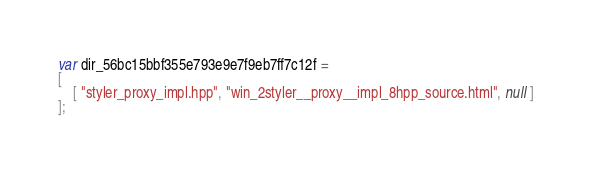<code> <loc_0><loc_0><loc_500><loc_500><_JavaScript_>var dir_56bc15bbf355e793e9e7f9eb7ff7c12f =
[
    [ "styler_proxy_impl.hpp", "win_2styler__proxy__impl_8hpp_source.html", null ]
];</code> 